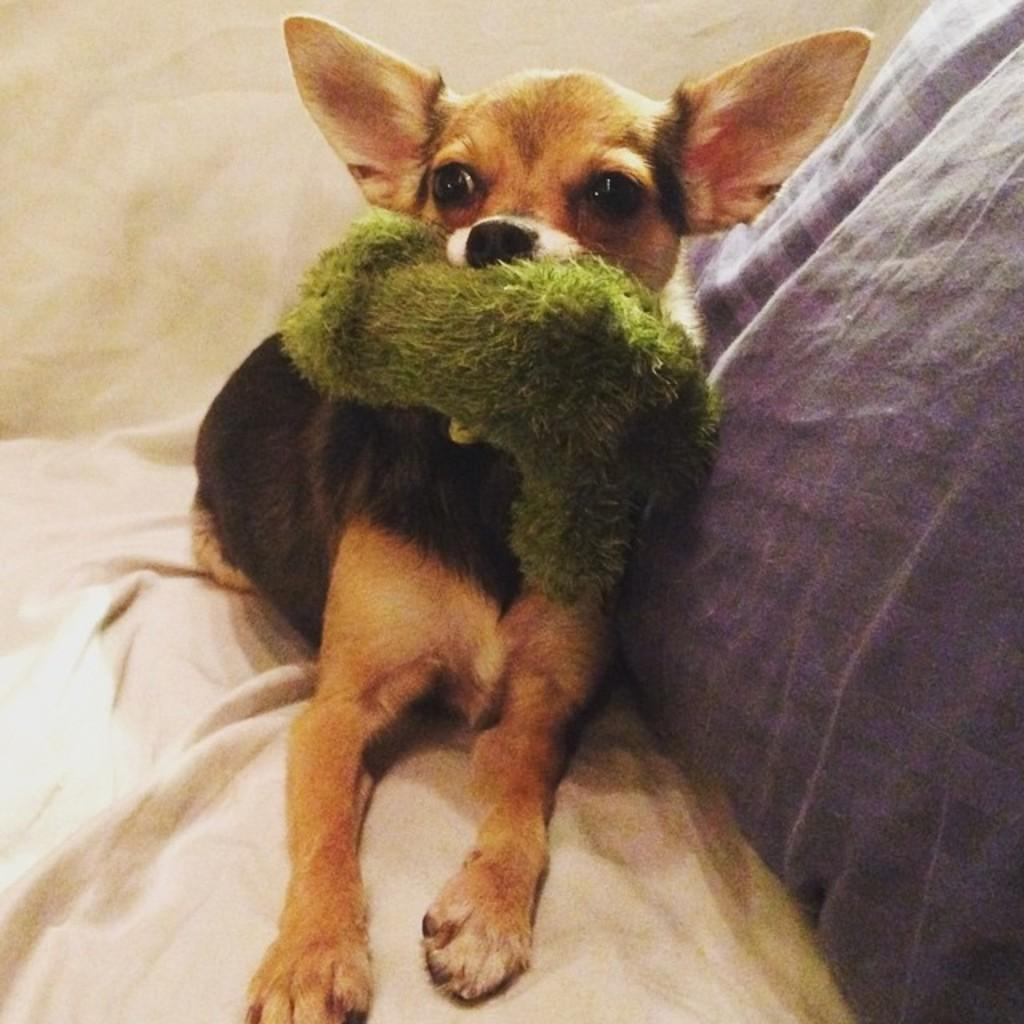What animal is present in the image? There is a dog in the image. What is the dog holding in the image? The dog is holding a toy. Where is the toy located in the image? The toy is visible on the bed. What can be seen on the right side of the image? There is a pillow on the right side of the image. What type of stove can be seen in the image? There is no stove present in the image. What kind of net is visible in the image? There is no net visible in the image. 